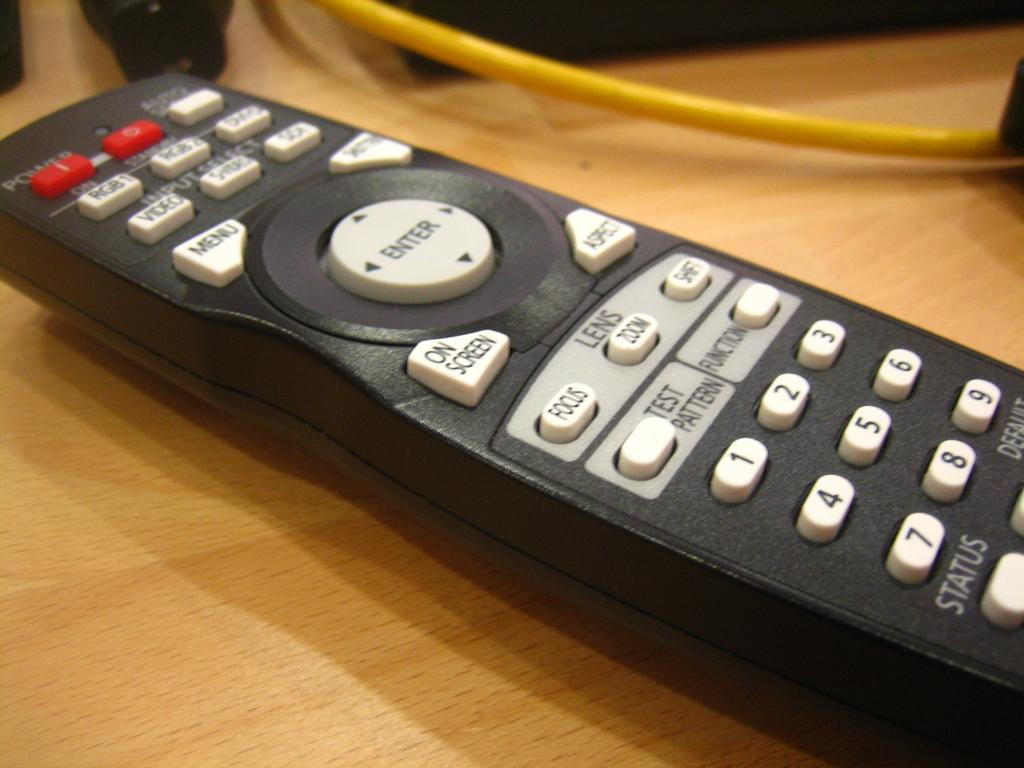Provide a one-sentence caption for the provided image. A TV remote has buttons with the numbers 1 through 9 and a menu button. 